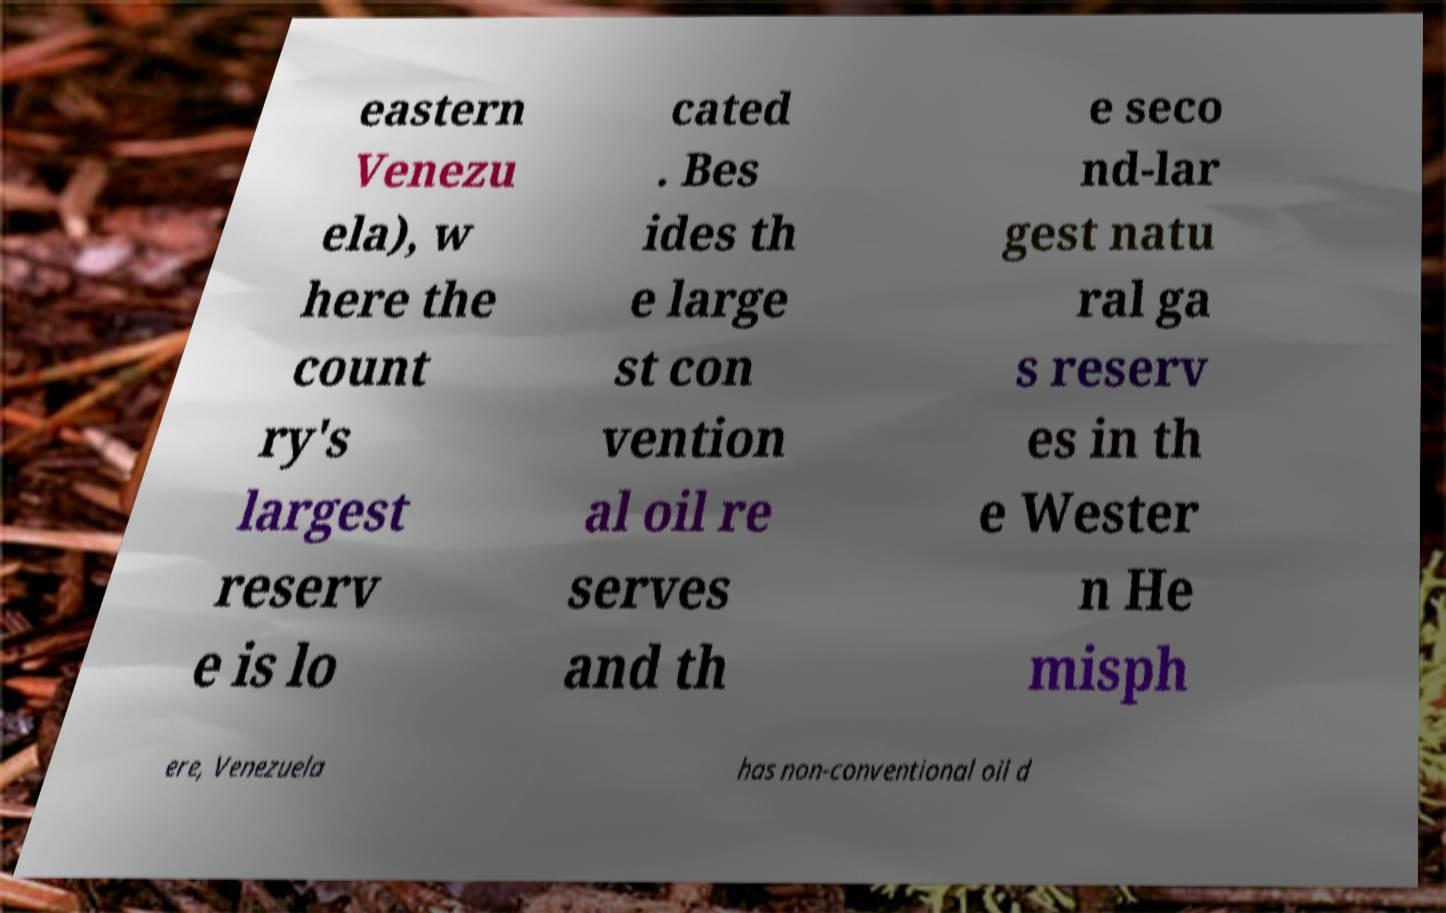Could you assist in decoding the text presented in this image and type it out clearly? eastern Venezu ela), w here the count ry's largest reserv e is lo cated . Bes ides th e large st con vention al oil re serves and th e seco nd-lar gest natu ral ga s reserv es in th e Wester n He misph ere, Venezuela has non-conventional oil d 